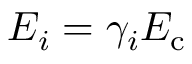Convert formula to latex. <formula><loc_0><loc_0><loc_500><loc_500>E _ { i } = \gamma _ { i } E _ { c }</formula> 